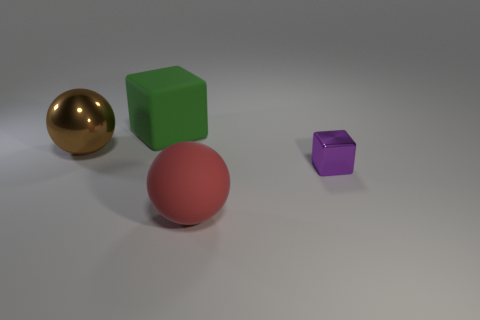Add 2 red objects. How many objects exist? 6 Subtract all purple blocks. How many blocks are left? 1 Subtract 0 green cylinders. How many objects are left? 4 Subtract all green spheres. Subtract all brown blocks. How many spheres are left? 2 Subtract all large yellow spheres. Subtract all small purple things. How many objects are left? 3 Add 3 rubber cubes. How many rubber cubes are left? 4 Add 4 large purple shiny cylinders. How many large purple shiny cylinders exist? 4 